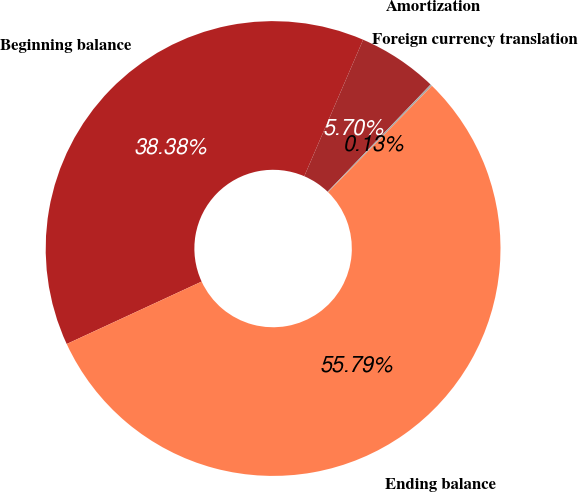Convert chart. <chart><loc_0><loc_0><loc_500><loc_500><pie_chart><fcel>Beginning balance<fcel>Amortization<fcel>Foreign currency translation<fcel>Ending balance<nl><fcel>38.38%<fcel>5.7%<fcel>0.13%<fcel>55.8%<nl></chart> 